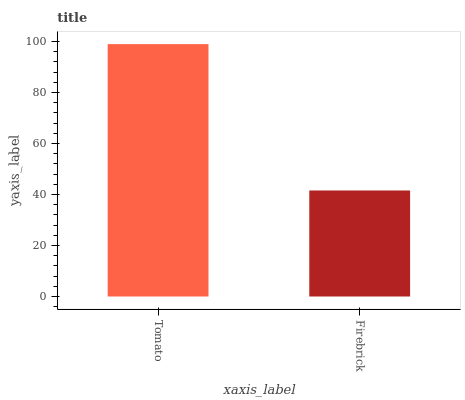Is Firebrick the minimum?
Answer yes or no. Yes. Is Tomato the maximum?
Answer yes or no. Yes. Is Firebrick the maximum?
Answer yes or no. No. Is Tomato greater than Firebrick?
Answer yes or no. Yes. Is Firebrick less than Tomato?
Answer yes or no. Yes. Is Firebrick greater than Tomato?
Answer yes or no. No. Is Tomato less than Firebrick?
Answer yes or no. No. Is Tomato the high median?
Answer yes or no. Yes. Is Firebrick the low median?
Answer yes or no. Yes. Is Firebrick the high median?
Answer yes or no. No. Is Tomato the low median?
Answer yes or no. No. 